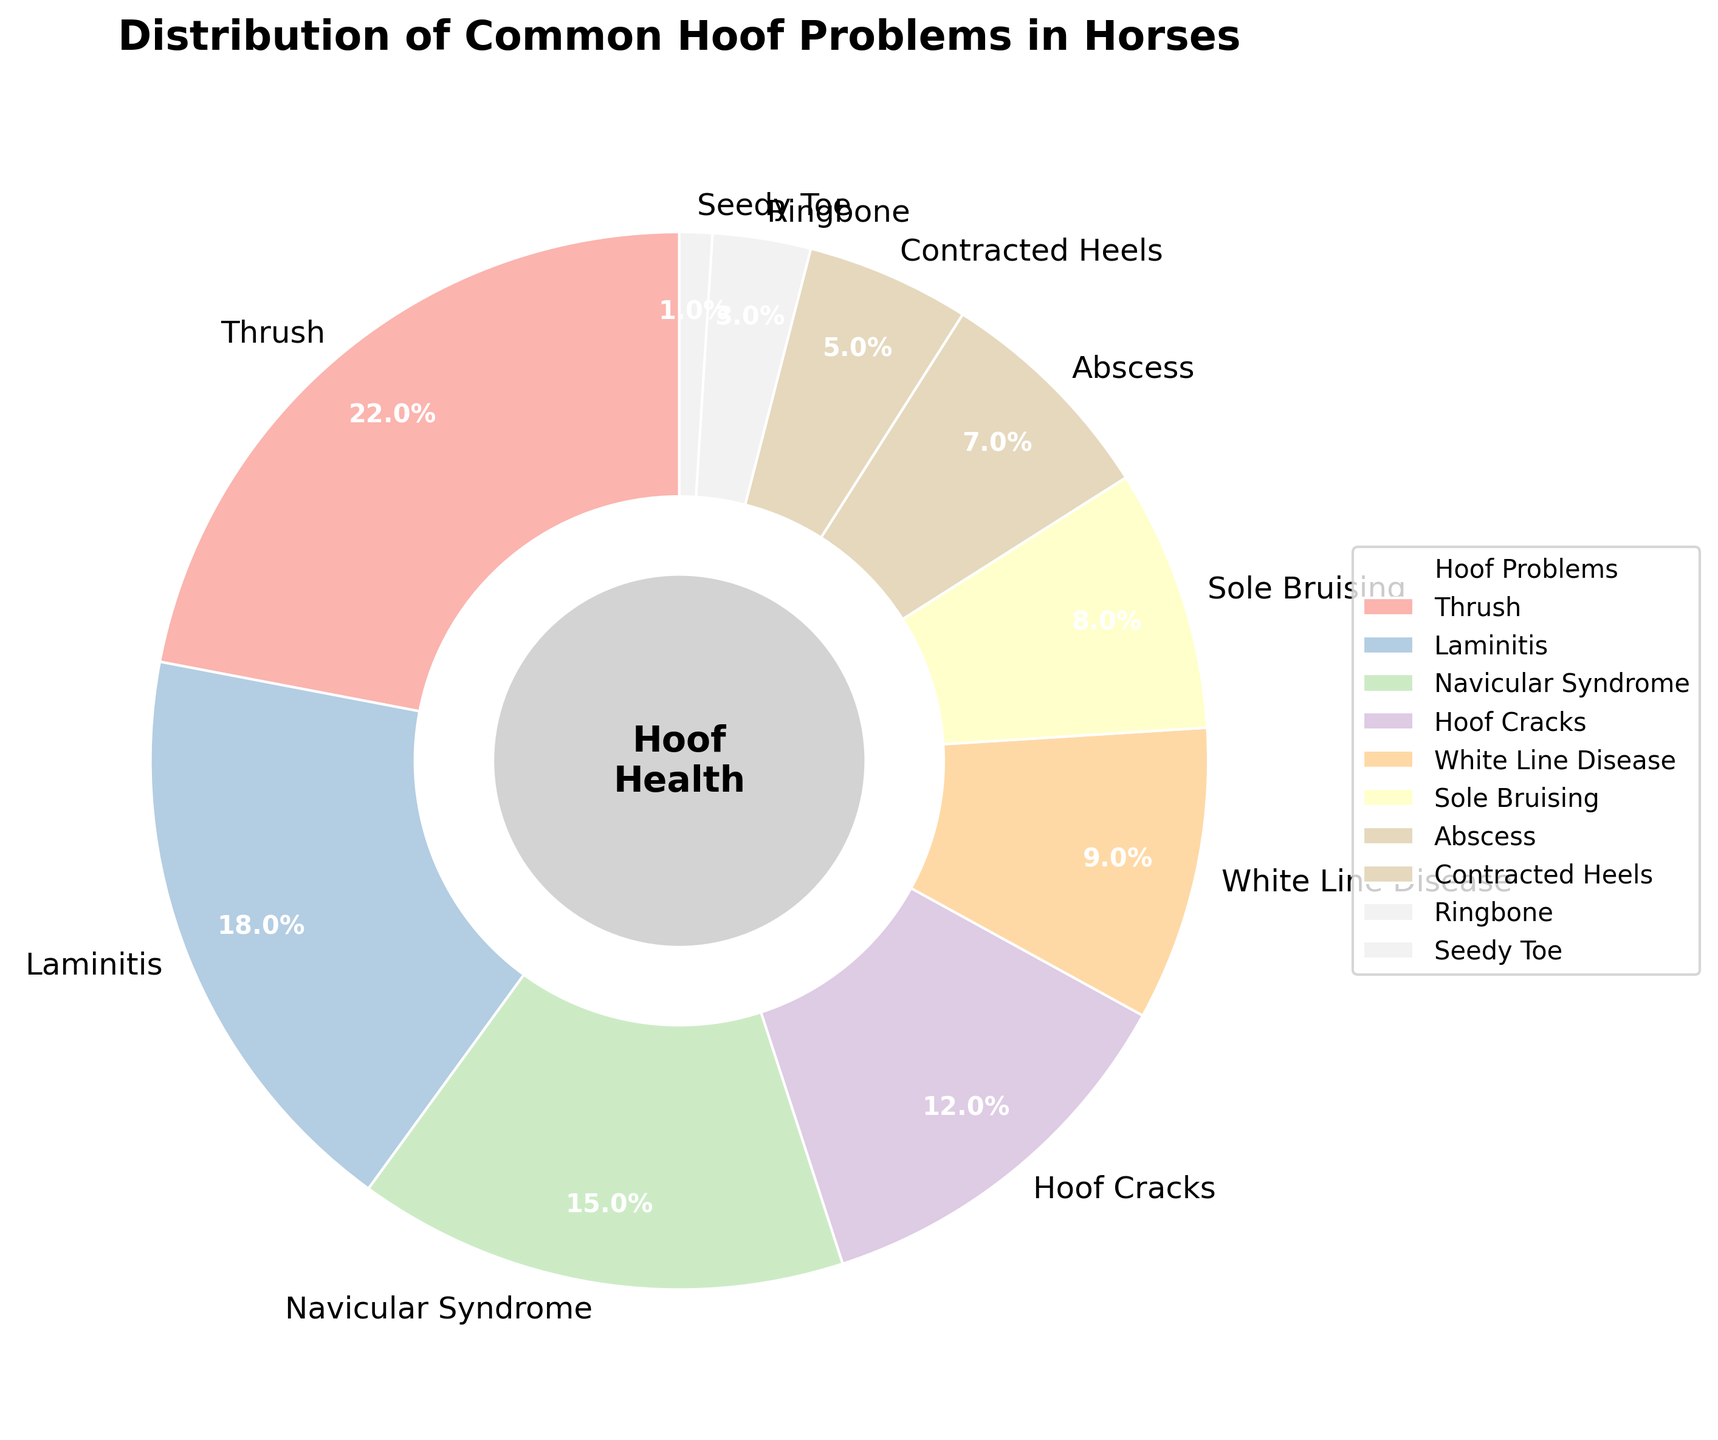What is the percentage of horses affected by Thrush? In the pie chart, Thrush is marked as having a percentage. It's listed at 22%, so this is the proportion of horses affected by Thrush.
Answer: 22% Which hoof problem has the second highest occurrence? From the pie chart, the problem with the highest percentage is Thrush at 22%. The second highest percentage, 18%, is for Laminitis.
Answer: Laminitis How much greater is the percentage of Thrush compared to Navicular Syndrome? Thrush is 22% and Navicular Syndrome is 15%. The difference between them is 22% - 15% = 7%.
Answer: 7% What is the combined percentage of horses affected by Sole Bruising, Abscess, and Contracted Heels? Sum the percentages of Sole Bruising (8%), Abscess (7%), and Contracted Heels (5%): 8% + 7% + 5% = 20%.
Answer: 20% Is Hoof Cracks more common than White Line Disease, and by how much? Hoof Cracks have a percentage of 12%, while White Line Disease has 9%. The difference is 12% - 9% = 3%.
Answer: Yes, by 3% Which hoof problem affects the smallest percentage of horses? By looking at the pie chart, Seedy Toe has the smallest percentage at 1%.
Answer: Seedy Toe If you combine the percentages of Thrush and Laminitis, what portion of the pie chart do they represent? Add the percentages of Thrush (22%) and Laminitis (18%): 22% + 18% = 40%.
Answer: 40% What is the median percentage from the given data of hoof problems? To find the median, list the percentages in ascending order: 1%, 3%, 5%, 7%, 8%, 9%, 12%, 15%, 18%, 22%. With 10 data points, the median will be the average of the 5th and 6th positions: (8% + 9%) / 2 = 8.5%.
Answer: 8.5% Which problems occupy the largest and smallest segments on the pie chart? The largest segment is Thrush at 22%, while the smallest segment is Seedy Toe at 1%.
Answer: Thrush (largest), Seedy Toe (smallest) 